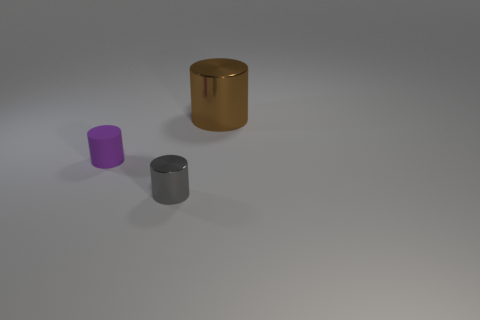What is the material of the brown object that is the same shape as the tiny gray object?
Your answer should be compact. Metal. Is there a gray object that is in front of the small cylinder that is in front of the purple matte cylinder to the left of the gray metallic object?
Your response must be concise. No. There is a tiny shiny thing; does it have the same shape as the object that is on the left side of the gray shiny cylinder?
Provide a short and direct response. Yes. Does the metallic cylinder that is left of the big brown cylinder have the same color as the cylinder behind the purple rubber thing?
Offer a very short reply. No. Is there a large yellow metal ball?
Your response must be concise. No. Is there a cyan thing made of the same material as the brown object?
Keep it short and to the point. No. Is there anything else that has the same material as the tiny purple cylinder?
Ensure brevity in your answer.  No. The rubber cylinder is what color?
Ensure brevity in your answer.  Purple. What is the color of the rubber object that is the same size as the gray shiny object?
Your answer should be very brief. Purple. How many matte things are tiny gray cylinders or large red cylinders?
Give a very brief answer. 0. 